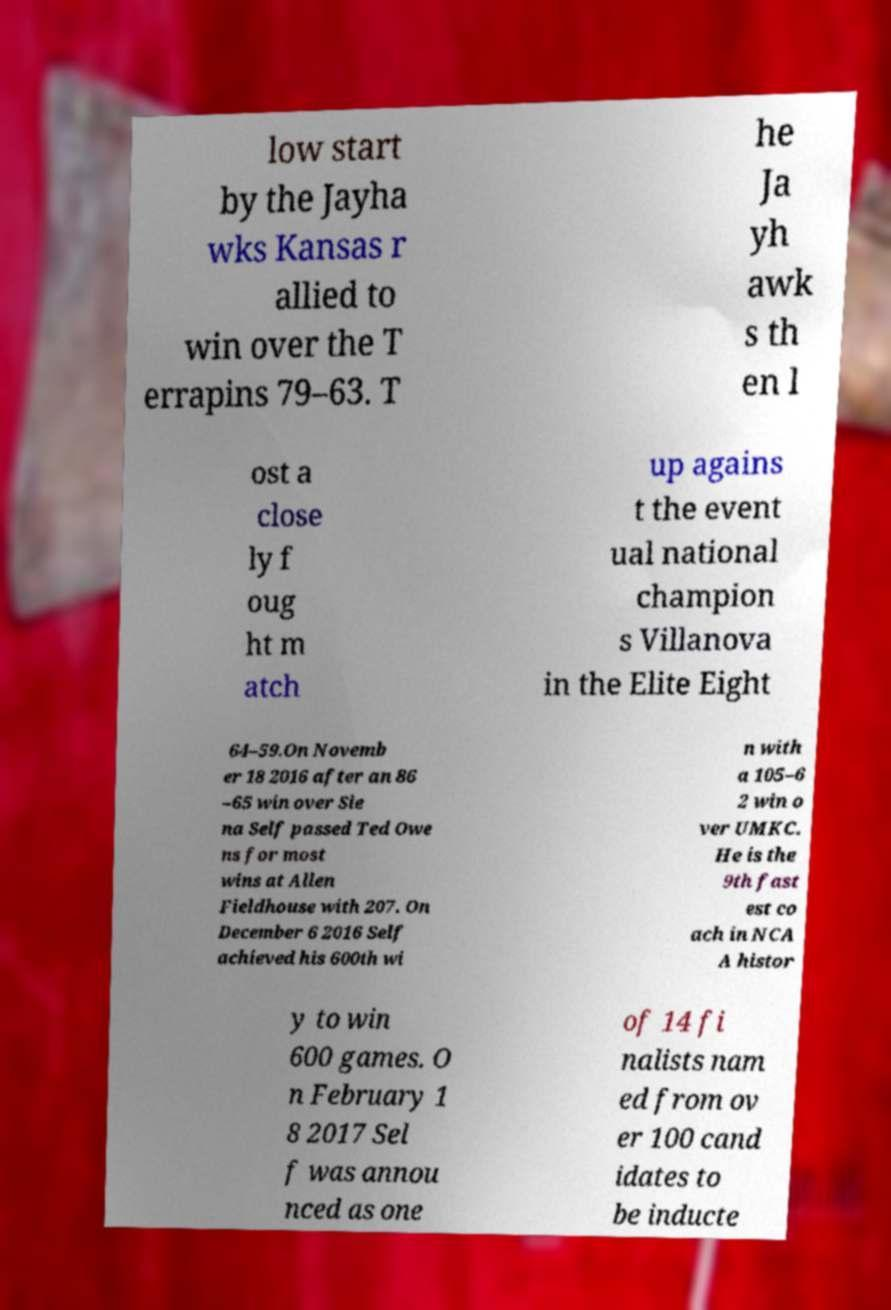I need the written content from this picture converted into text. Can you do that? low start by the Jayha wks Kansas r allied to win over the T errapins 79–63. T he Ja yh awk s th en l ost a close ly f oug ht m atch up agains t the event ual national champion s Villanova in the Elite Eight 64–59.On Novemb er 18 2016 after an 86 –65 win over Sie na Self passed Ted Owe ns for most wins at Allen Fieldhouse with 207. On December 6 2016 Self achieved his 600th wi n with a 105–6 2 win o ver UMKC. He is the 9th fast est co ach in NCA A histor y to win 600 games. O n February 1 8 2017 Sel f was annou nced as one of 14 fi nalists nam ed from ov er 100 cand idates to be inducte 